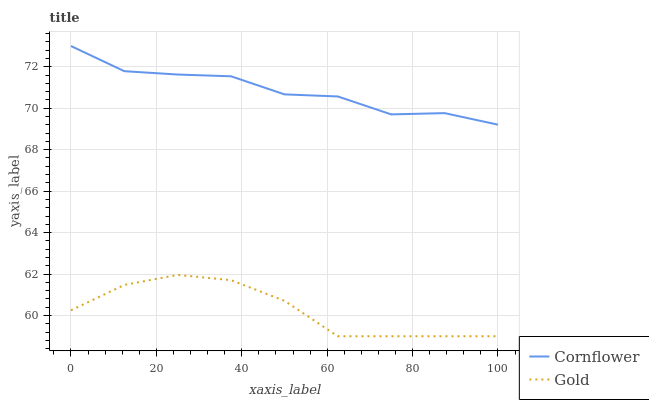Does Gold have the minimum area under the curve?
Answer yes or no. Yes. Does Cornflower have the maximum area under the curve?
Answer yes or no. Yes. Does Gold have the maximum area under the curve?
Answer yes or no. No. Is Gold the smoothest?
Answer yes or no. Yes. Is Cornflower the roughest?
Answer yes or no. Yes. Is Gold the roughest?
Answer yes or no. No. Does Cornflower have the highest value?
Answer yes or no. Yes. Does Gold have the highest value?
Answer yes or no. No. Is Gold less than Cornflower?
Answer yes or no. Yes. Is Cornflower greater than Gold?
Answer yes or no. Yes. Does Gold intersect Cornflower?
Answer yes or no. No. 